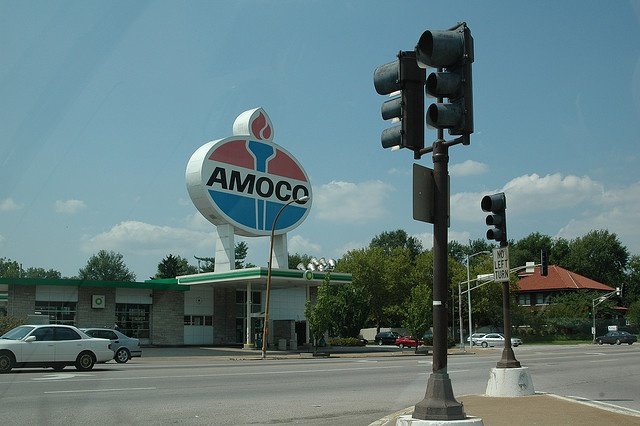Describe the objects in this image and their specific colors. I can see traffic light in gray, black, and purple tones, car in gray, black, and darkgray tones, traffic light in gray, black, and purple tones, car in gray, black, and teal tones, and traffic light in gray, black, darkgray, and teal tones in this image. 